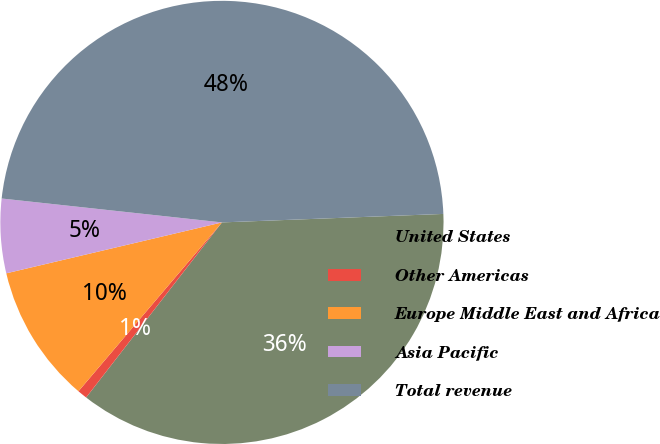Convert chart to OTSL. <chart><loc_0><loc_0><loc_500><loc_500><pie_chart><fcel>United States<fcel>Other Americas<fcel>Europe Middle East and Africa<fcel>Asia Pacific<fcel>Total revenue<nl><fcel>36.11%<fcel>0.71%<fcel>10.1%<fcel>5.41%<fcel>47.67%<nl></chart> 